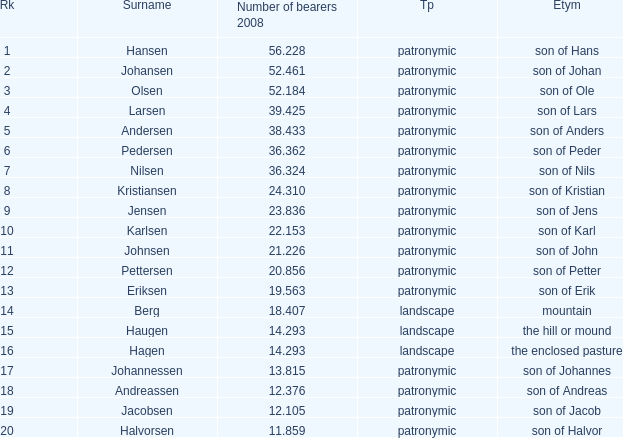Could you parse the entire table? {'header': ['Rk', 'Surname', 'Number of bearers 2008', 'Tp', 'Etym'], 'rows': [['1', 'Hansen', '56.228', 'patronymic', 'son of Hans'], ['2', 'Johansen', '52.461', 'patronymic', 'son of Johan'], ['3', 'Olsen', '52.184', 'patronymic', 'son of Ole'], ['4', 'Larsen', '39.425', 'patronymic', 'son of Lars'], ['5', 'Andersen', '38.433', 'patronymic', 'son of Anders'], ['6', 'Pedersen', '36.362', 'patronymic', 'son of Peder'], ['7', 'Nilsen', '36.324', 'patronymic', 'son of Nils'], ['8', 'Kristiansen', '24.310', 'patronymic', 'son of Kristian'], ['9', 'Jensen', '23.836', 'patronymic', 'son of Jens'], ['10', 'Karlsen', '22.153', 'patronymic', 'son of Karl'], ['11', 'Johnsen', '21.226', 'patronymic', 'son of John'], ['12', 'Pettersen', '20.856', 'patronymic', 'son of Petter'], ['13', 'Eriksen', '19.563', 'patronymic', 'son of Erik'], ['14', 'Berg', '18.407', 'landscape', 'mountain'], ['15', 'Haugen', '14.293', 'landscape', 'the hill or mound'], ['16', 'Hagen', '14.293', 'landscape', 'the enclosed pasture'], ['17', 'Johannessen', '13.815', 'patronymic', 'son of Johannes'], ['18', 'Andreassen', '12.376', 'patronymic', 'son of Andreas'], ['19', 'Jacobsen', '12.105', 'patronymic', 'son of Jacob'], ['20', 'Halvorsen', '11.859', 'patronymic', 'son of Halvor']]} What is Type, when Number of Bearers 2008 is greater than 12.376, when Rank is greater than 3, and when Etymology is Son of Jens? Patronymic. 